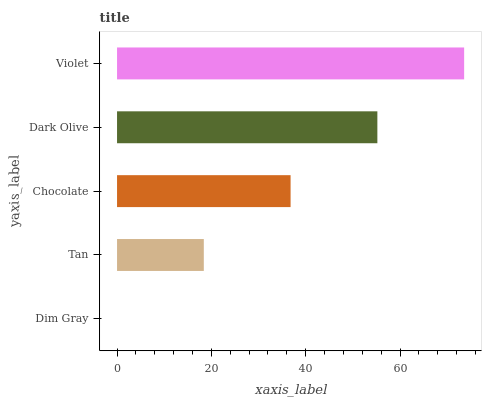Is Dim Gray the minimum?
Answer yes or no. Yes. Is Violet the maximum?
Answer yes or no. Yes. Is Tan the minimum?
Answer yes or no. No. Is Tan the maximum?
Answer yes or no. No. Is Tan greater than Dim Gray?
Answer yes or no. Yes. Is Dim Gray less than Tan?
Answer yes or no. Yes. Is Dim Gray greater than Tan?
Answer yes or no. No. Is Tan less than Dim Gray?
Answer yes or no. No. Is Chocolate the high median?
Answer yes or no. Yes. Is Chocolate the low median?
Answer yes or no. Yes. Is Dim Gray the high median?
Answer yes or no. No. Is Tan the low median?
Answer yes or no. No. 